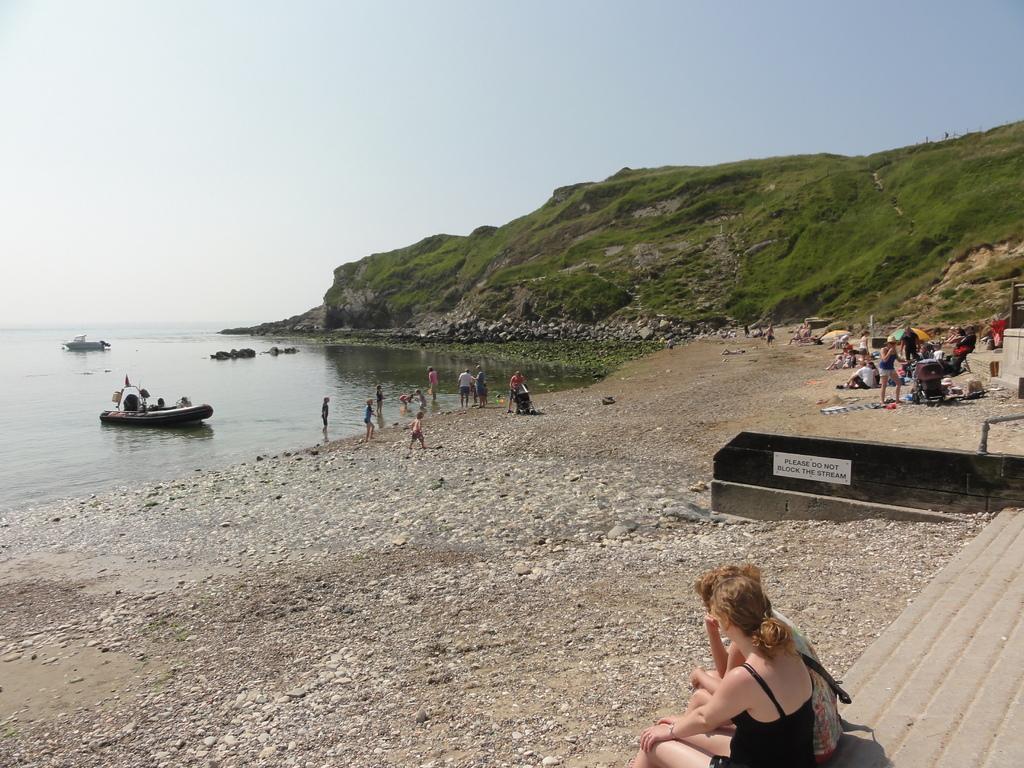Describe this image in one or two sentences. This is an outside view. At the bottom two persons are sitting facing towards the left side. On the right side there is a wall and I can see many people. Few are sitting, few are standing. There is an umbrella. In the background there is a hill. On the left side, I can see few boats on the water and few people are standing on the ground. At the top of the image I can see the sky. 